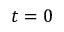Convert formula to latex. <formula><loc_0><loc_0><loc_500><loc_500>t = 0</formula> 